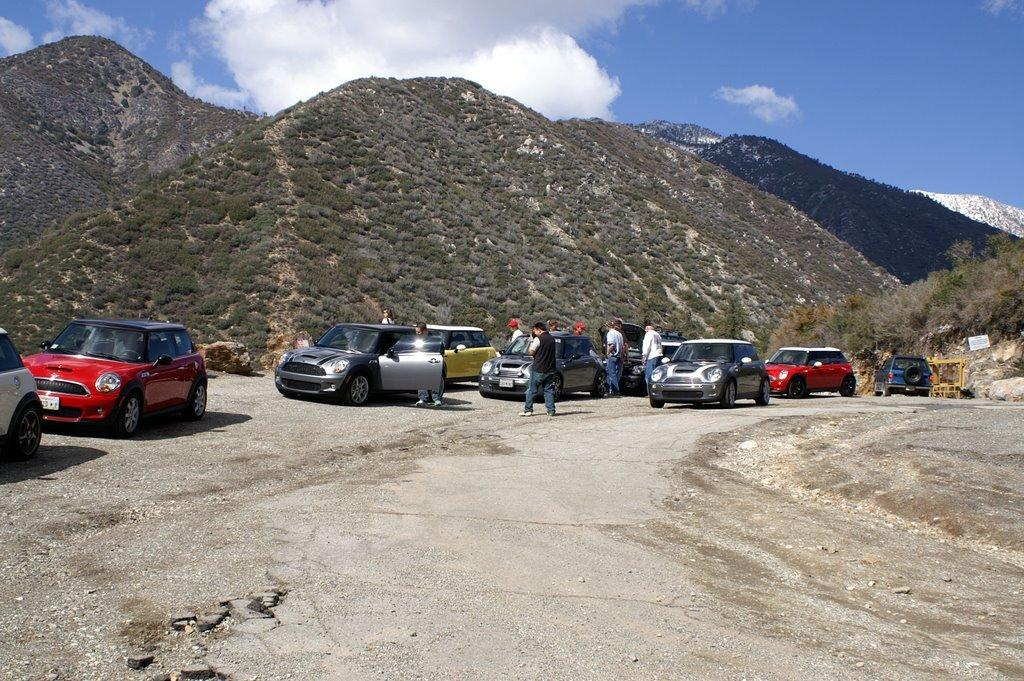What can be seen on the road in the image? There are cars parked on the road in the image. What else is visible in the image besides the parked cars? There are people standing in the image. What type of natural features can be seen in the background of the image? Hills and mountains are visible in the background of the image. What is visible above the hills and mountains in the image? The sky is visible in the image. What is the condition of the sky in the image? Clouds are present in the sky. What direction are the cars blowing in the image? There are no cars blowing in the image; they are parked on the road. Who is the representative of the people standing in the image? There is no specific representative mentioned or implied in the image. 